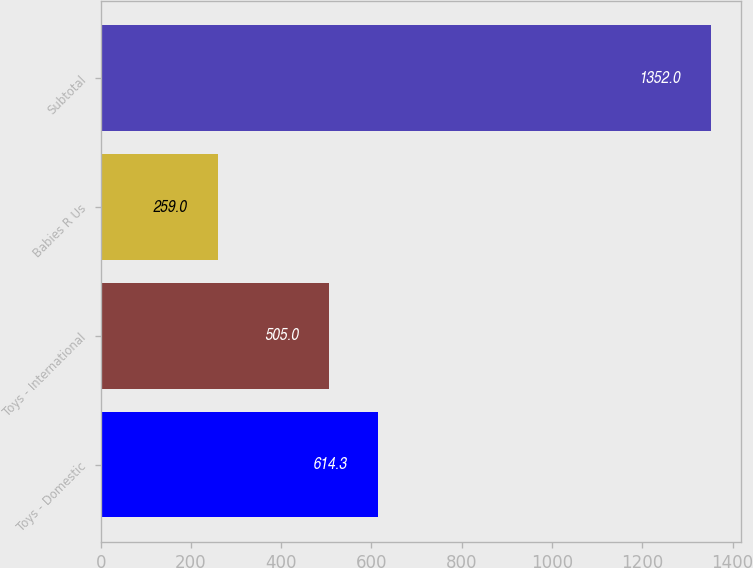<chart> <loc_0><loc_0><loc_500><loc_500><bar_chart><fcel>Toys - Domestic<fcel>Toys - International<fcel>Babies R Us<fcel>Subtotal<nl><fcel>614.3<fcel>505<fcel>259<fcel>1352<nl></chart> 